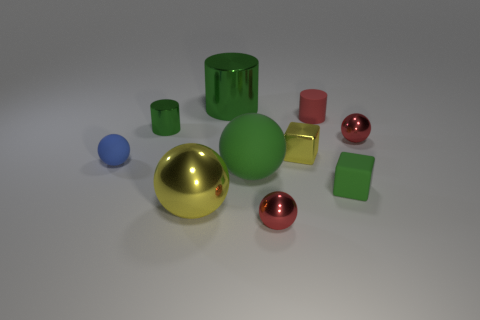Subtract all matte spheres. How many spheres are left? 3 Subtract all red cylinders. How many cylinders are left? 2 Subtract 0 gray blocks. How many objects are left? 10 Subtract all cubes. How many objects are left? 8 Subtract 1 blocks. How many blocks are left? 1 Subtract all purple balls. Subtract all purple cubes. How many balls are left? 5 Subtract all brown cubes. How many red balls are left? 2 Subtract all small gray shiny cylinders. Subtract all small red balls. How many objects are left? 8 Add 4 small red cylinders. How many small red cylinders are left? 5 Add 8 big cylinders. How many big cylinders exist? 9 